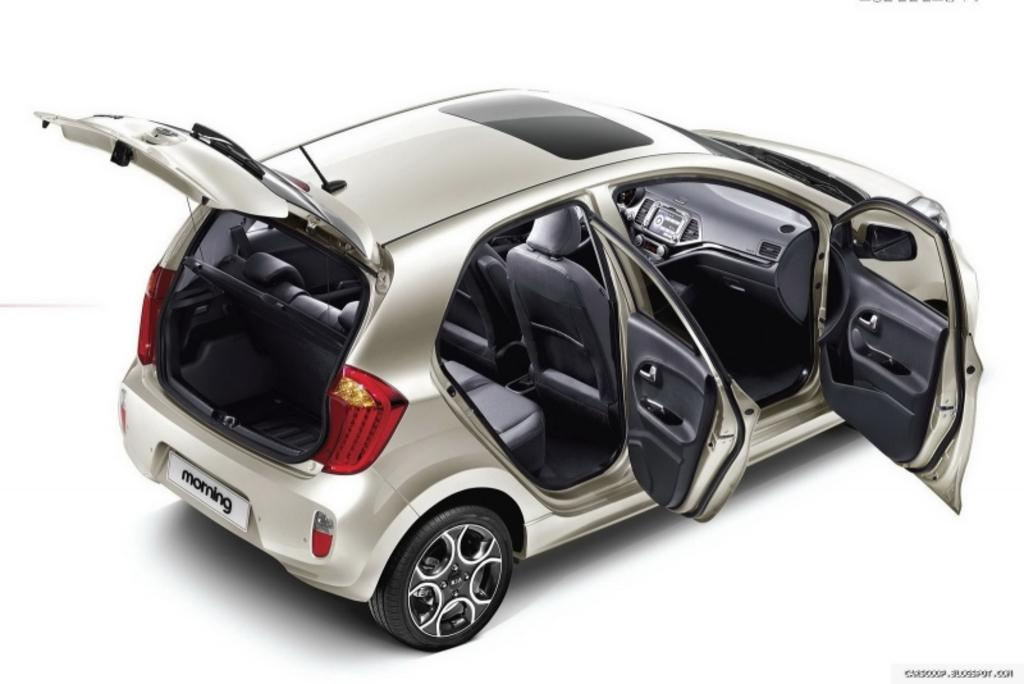How many seats are available in the car in the image? The car in the image has 5 seats. What is the state of the car doors in the image? All the car doors are open. What can be seen on the back of the car? There is a white registration plate at the back of the car. What is written on the registration plate? The registration plate has the word "morning" written on it. What is the color of the background in the image? The background of the image is white. How many dogs are sitting on the car in the image? There are no dogs present in the image; the focus is on the car and its features. 